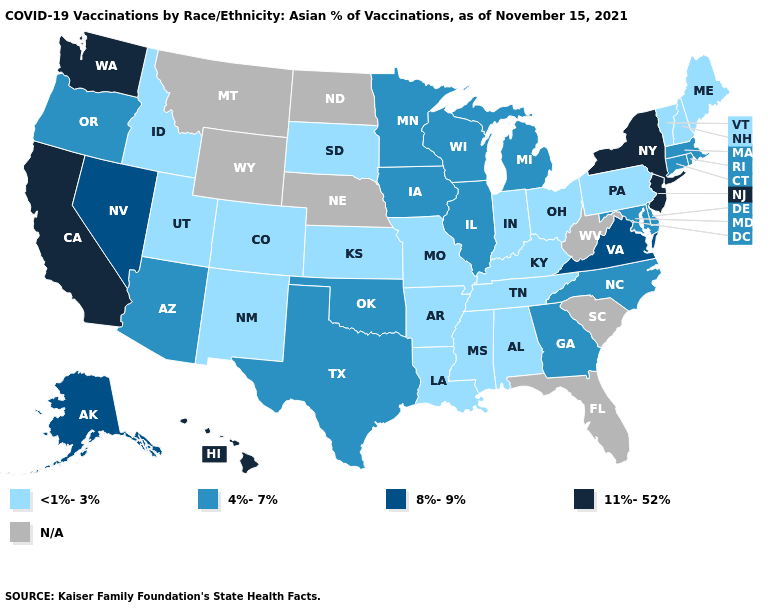Among the states that border Ohio , which have the highest value?
Short answer required. Michigan. Does the map have missing data?
Concise answer only. Yes. Name the states that have a value in the range 8%-9%?
Concise answer only. Alaska, Nevada, Virginia. Does Pennsylvania have the lowest value in the USA?
Be succinct. Yes. What is the value of Utah?
Give a very brief answer. <1%-3%. Which states have the lowest value in the USA?
Be succinct. Alabama, Arkansas, Colorado, Idaho, Indiana, Kansas, Kentucky, Louisiana, Maine, Mississippi, Missouri, New Hampshire, New Mexico, Ohio, Pennsylvania, South Dakota, Tennessee, Utah, Vermont. What is the value of North Carolina?
Quick response, please. 4%-7%. Among the states that border New Hampshire , does Massachusetts have the highest value?
Answer briefly. Yes. Among the states that border Delaware , which have the lowest value?
Keep it brief. Pennsylvania. Which states have the lowest value in the USA?
Quick response, please. Alabama, Arkansas, Colorado, Idaho, Indiana, Kansas, Kentucky, Louisiana, Maine, Mississippi, Missouri, New Hampshire, New Mexico, Ohio, Pennsylvania, South Dakota, Tennessee, Utah, Vermont. Among the states that border Vermont , which have the highest value?
Short answer required. New York. Does Arizona have the lowest value in the USA?
Give a very brief answer. No. What is the highest value in the USA?
Give a very brief answer. 11%-52%. What is the value of Virginia?
Concise answer only. 8%-9%. 